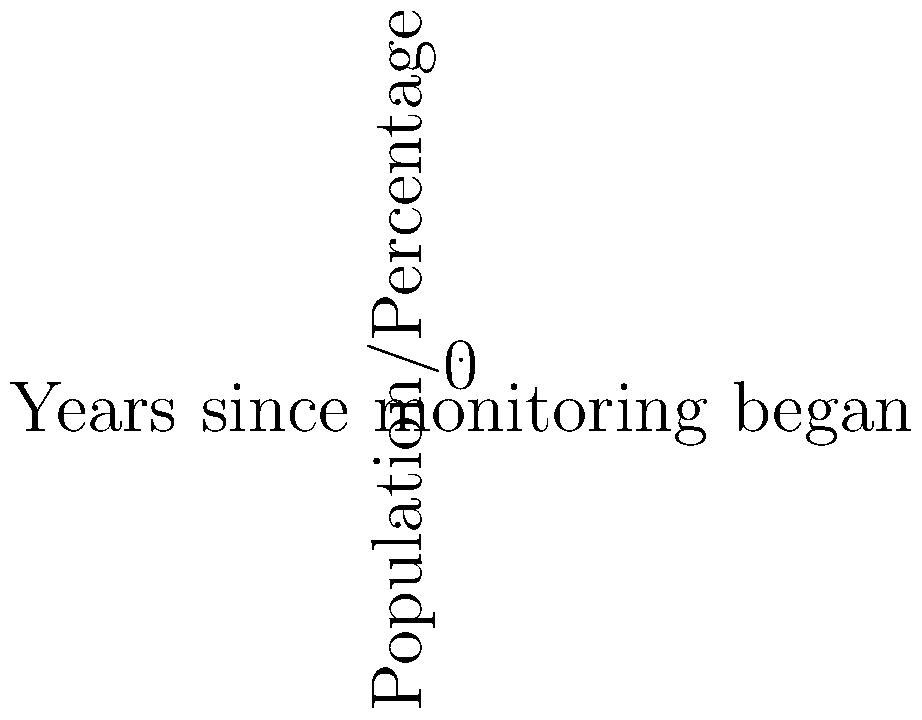The graph shows the relationship between deforestation rates and wildlife population decline over a 50-year period. The blue line represents the percentage of forest remaining, starting at 100% and decreasing by 2% each year. The red line represents the wildlife population, starting at 80% and decreasing by 0.5% each year. After how many years will the percentage of forest remaining be equal to the wildlife population percentage? To solve this problem, we need to find the point where the two lines intersect. We can do this by setting up an equation:

1) Let $x$ be the number of years.
2) Forest remaining equation: $y = 100 - 2x$
3) Wildlife population equation: $y = 80 - 0.5x$

At the intersection point, these will be equal:

4) $100 - 2x = 80 - 0.5x$

Now, let's solve this equation:

5) $100 - 2x = 80 - 0.5x$
6) $100 - 80 = 2x - 0.5x$
7) $20 = 1.5x$
8) $x = 20 / 1.5 = 13.33$

Since we're dealing with years, we round to the nearest whole number.
Answer: 13 years 